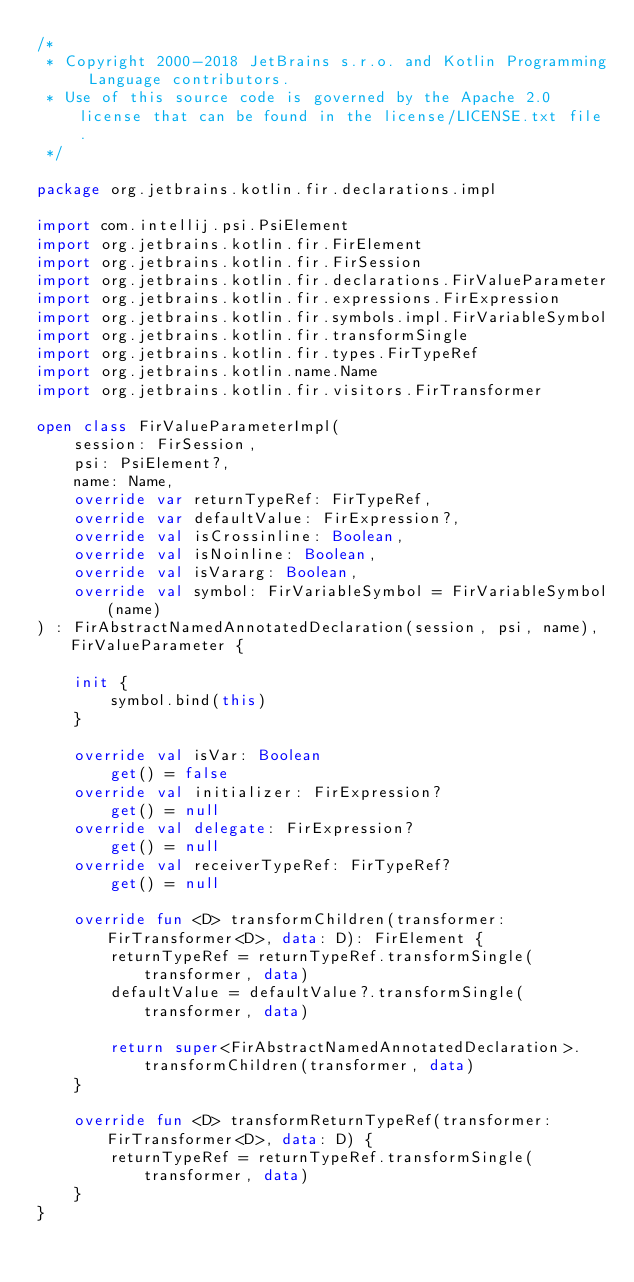Convert code to text. <code><loc_0><loc_0><loc_500><loc_500><_Kotlin_>/*
 * Copyright 2000-2018 JetBrains s.r.o. and Kotlin Programming Language contributors.
 * Use of this source code is governed by the Apache 2.0 license that can be found in the license/LICENSE.txt file.
 */

package org.jetbrains.kotlin.fir.declarations.impl

import com.intellij.psi.PsiElement
import org.jetbrains.kotlin.fir.FirElement
import org.jetbrains.kotlin.fir.FirSession
import org.jetbrains.kotlin.fir.declarations.FirValueParameter
import org.jetbrains.kotlin.fir.expressions.FirExpression
import org.jetbrains.kotlin.fir.symbols.impl.FirVariableSymbol
import org.jetbrains.kotlin.fir.transformSingle
import org.jetbrains.kotlin.fir.types.FirTypeRef
import org.jetbrains.kotlin.name.Name
import org.jetbrains.kotlin.fir.visitors.FirTransformer

open class FirValueParameterImpl(
    session: FirSession,
    psi: PsiElement?,
    name: Name,
    override var returnTypeRef: FirTypeRef,
    override var defaultValue: FirExpression?,
    override val isCrossinline: Boolean,
    override val isNoinline: Boolean,
    override val isVararg: Boolean,
    override val symbol: FirVariableSymbol = FirVariableSymbol(name)
) : FirAbstractNamedAnnotatedDeclaration(session, psi, name), FirValueParameter {

    init {
        symbol.bind(this)
    }

    override val isVar: Boolean
        get() = false
    override val initializer: FirExpression?
        get() = null
    override val delegate: FirExpression?
        get() = null
    override val receiverTypeRef: FirTypeRef?
        get() = null

    override fun <D> transformChildren(transformer: FirTransformer<D>, data: D): FirElement {
        returnTypeRef = returnTypeRef.transformSingle(transformer, data)
        defaultValue = defaultValue?.transformSingle(transformer, data)

        return super<FirAbstractNamedAnnotatedDeclaration>.transformChildren(transformer, data)
    }

    override fun <D> transformReturnTypeRef(transformer: FirTransformer<D>, data: D) {
        returnTypeRef = returnTypeRef.transformSingle(transformer, data)
    }
}</code> 